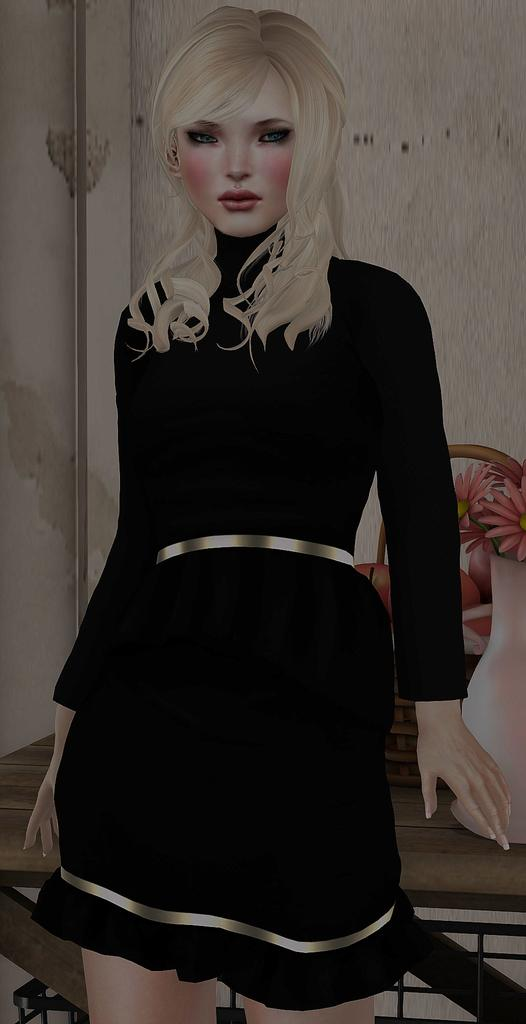What type of media is the image? The image is an animation. Who is present in the image? There is a girl in the image. What is behind the girl in the image? There is a table behind the girl. What is on the table in the image? There is a flower vase and fruits on the table. What can be seen in the background of the image? There is a wall in the background of the image. What type of whistle is being used by the team in the image? There is no whistle or team present in the image; it features an animated girl and objects on a table. 